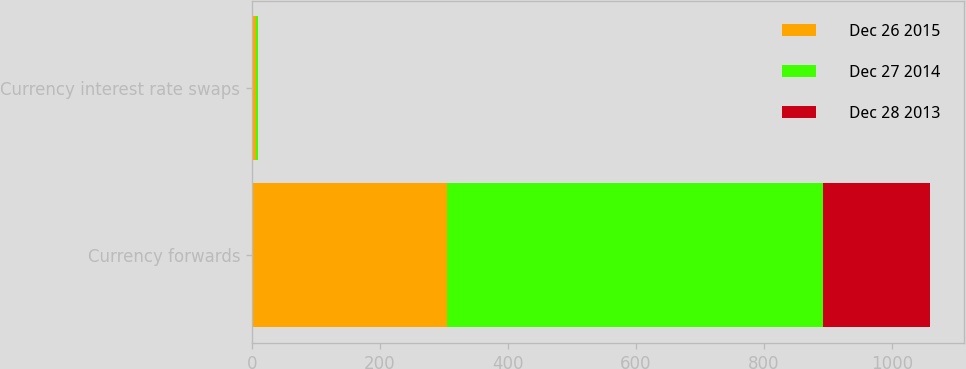Convert chart to OTSL. <chart><loc_0><loc_0><loc_500><loc_500><stacked_bar_chart><ecel><fcel>Currency forwards<fcel>Currency interest rate swaps<nl><fcel>Dec 26 2015<fcel>305<fcel>7<nl><fcel>Dec 27 2014<fcel>587<fcel>2<nl><fcel>Dec 28 2013<fcel>167<fcel>1<nl></chart> 